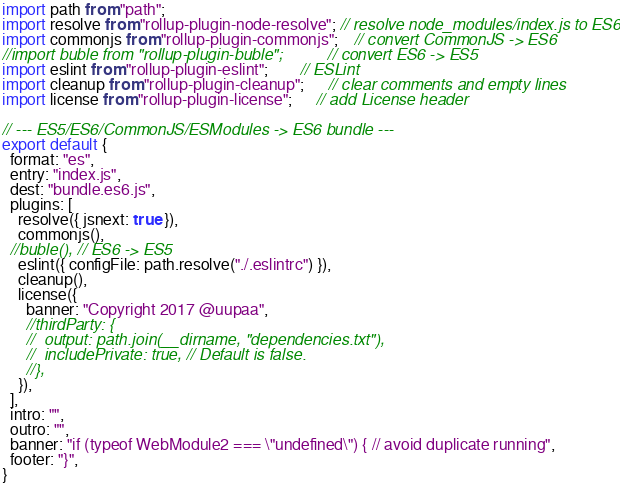<code> <loc_0><loc_0><loc_500><loc_500><_JavaScript_>import path from "path";
import resolve from "rollup-plugin-node-resolve"; // resolve node_modules/index.js to ES6
import commonjs from "rollup-plugin-commonjs";    // convert CommonJS -> ES6
//import buble from "rollup-plugin-buble";          // convert ES6 -> ES5
import eslint from "rollup-plugin-eslint";        // ESLint
import cleanup from "rollup-plugin-cleanup";      // clear comments and empty lines
import license from "rollup-plugin-license";      // add License header

// --- ES5/ES6/CommonJS/ESModules -> ES6 bundle ---
export default {
  format: "es",
  entry: "index.js",
  dest: "bundle.es6.js",
  plugins: [
    resolve({ jsnext: true }),
    commonjs(),
  //buble(), // ES6 -> ES5
    eslint({ configFile: path.resolve("./.eslintrc") }),
    cleanup(),
    license({
      banner: "Copyright 2017 @uupaa",
      //thirdParty: {
      //  output: path.join(__dirname, "dependencies.txt"),
      //  includePrivate: true, // Default is false.
      //},
    }),
  ],
  intro: "",
  outro: "",
  banner: "if (typeof WebModule2 === \"undefined\") { // avoid duplicate running",
  footer: "}",
}

</code> 